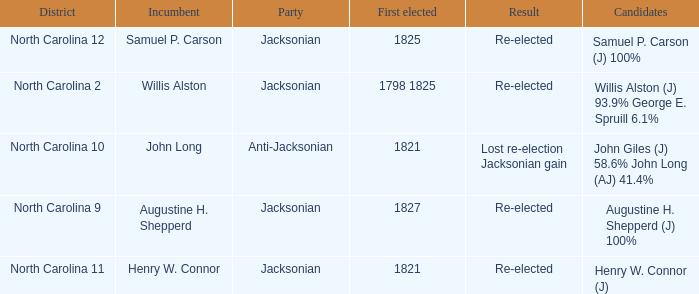Name the result for  augustine h. shepperd (j) 100% Re-elected. 